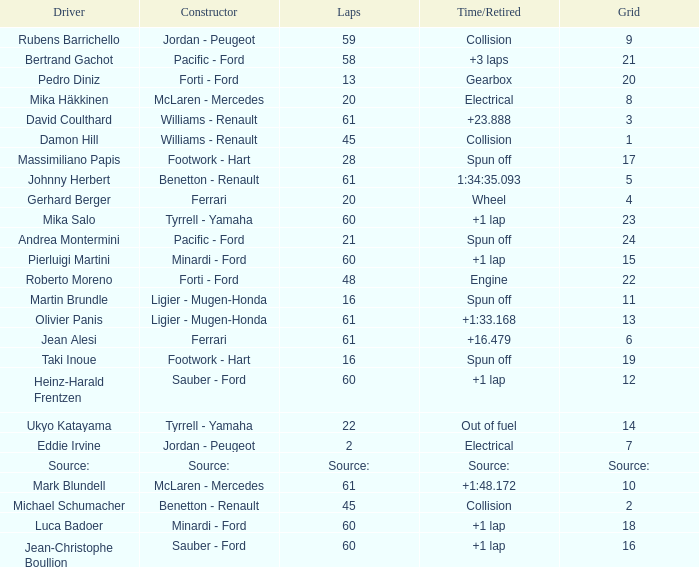Would you mind parsing the complete table? {'header': ['Driver', 'Constructor', 'Laps', 'Time/Retired', 'Grid'], 'rows': [['Rubens Barrichello', 'Jordan - Peugeot', '59', 'Collision', '9'], ['Bertrand Gachot', 'Pacific - Ford', '58', '+3 laps', '21'], ['Pedro Diniz', 'Forti - Ford', '13', 'Gearbox', '20'], ['Mika Häkkinen', 'McLaren - Mercedes', '20', 'Electrical', '8'], ['David Coulthard', 'Williams - Renault', '61', '+23.888', '3'], ['Damon Hill', 'Williams - Renault', '45', 'Collision', '1'], ['Massimiliano Papis', 'Footwork - Hart', '28', 'Spun off', '17'], ['Johnny Herbert', 'Benetton - Renault', '61', '1:34:35.093', '5'], ['Gerhard Berger', 'Ferrari', '20', 'Wheel', '4'], ['Mika Salo', 'Tyrrell - Yamaha', '60', '+1 lap', '23'], ['Andrea Montermini', 'Pacific - Ford', '21', 'Spun off', '24'], ['Pierluigi Martini', 'Minardi - Ford', '60', '+1 lap', '15'], ['Roberto Moreno', 'Forti - Ford', '48', 'Engine', '22'], ['Martin Brundle', 'Ligier - Mugen-Honda', '16', 'Spun off', '11'], ['Olivier Panis', 'Ligier - Mugen-Honda', '61', '+1:33.168', '13'], ['Jean Alesi', 'Ferrari', '61', '+16.479', '6'], ['Taki Inoue', 'Footwork - Hart', '16', 'Spun off', '19'], ['Heinz-Harald Frentzen', 'Sauber - Ford', '60', '+1 lap', '12'], ['Ukyo Katayama', 'Tyrrell - Yamaha', '22', 'Out of fuel', '14'], ['Eddie Irvine', 'Jordan - Peugeot', '2', 'Electrical', '7'], ['Source:', 'Source:', 'Source:', 'Source:', 'Source:'], ['Mark Blundell', 'McLaren - Mercedes', '61', '+1:48.172', '10'], ['Michael Schumacher', 'Benetton - Renault', '45', 'Collision', '2'], ['Luca Badoer', 'Minardi - Ford', '60', '+1 lap', '18'], ['Jean-Christophe Boullion', 'Sauber - Ford', '60', '+1 lap', '16']]} What's the time/retired for a grid of 14? Out of fuel. 